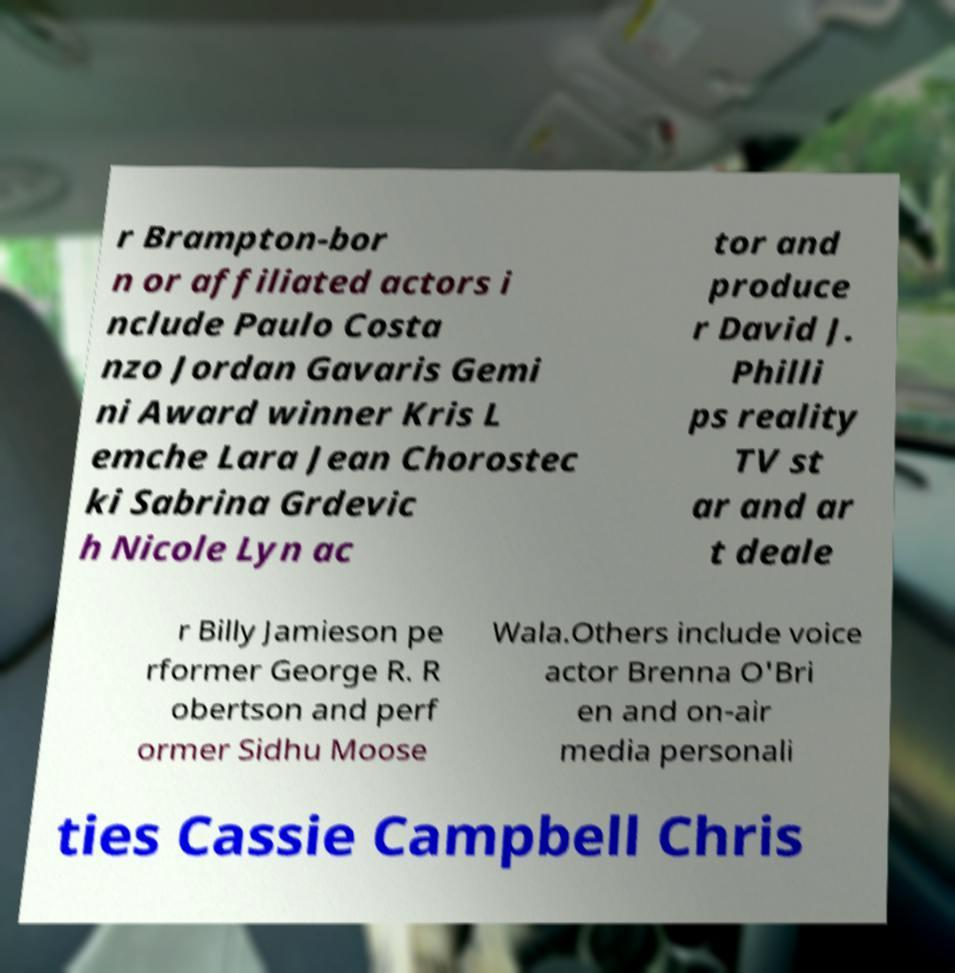What messages or text are displayed in this image? I need them in a readable, typed format. r Brampton-bor n or affiliated actors i nclude Paulo Costa nzo Jordan Gavaris Gemi ni Award winner Kris L emche Lara Jean Chorostec ki Sabrina Grdevic h Nicole Lyn ac tor and produce r David J. Philli ps reality TV st ar and ar t deale r Billy Jamieson pe rformer George R. R obertson and perf ormer Sidhu Moose Wala.Others include voice actor Brenna O'Bri en and on-air media personali ties Cassie Campbell Chris 